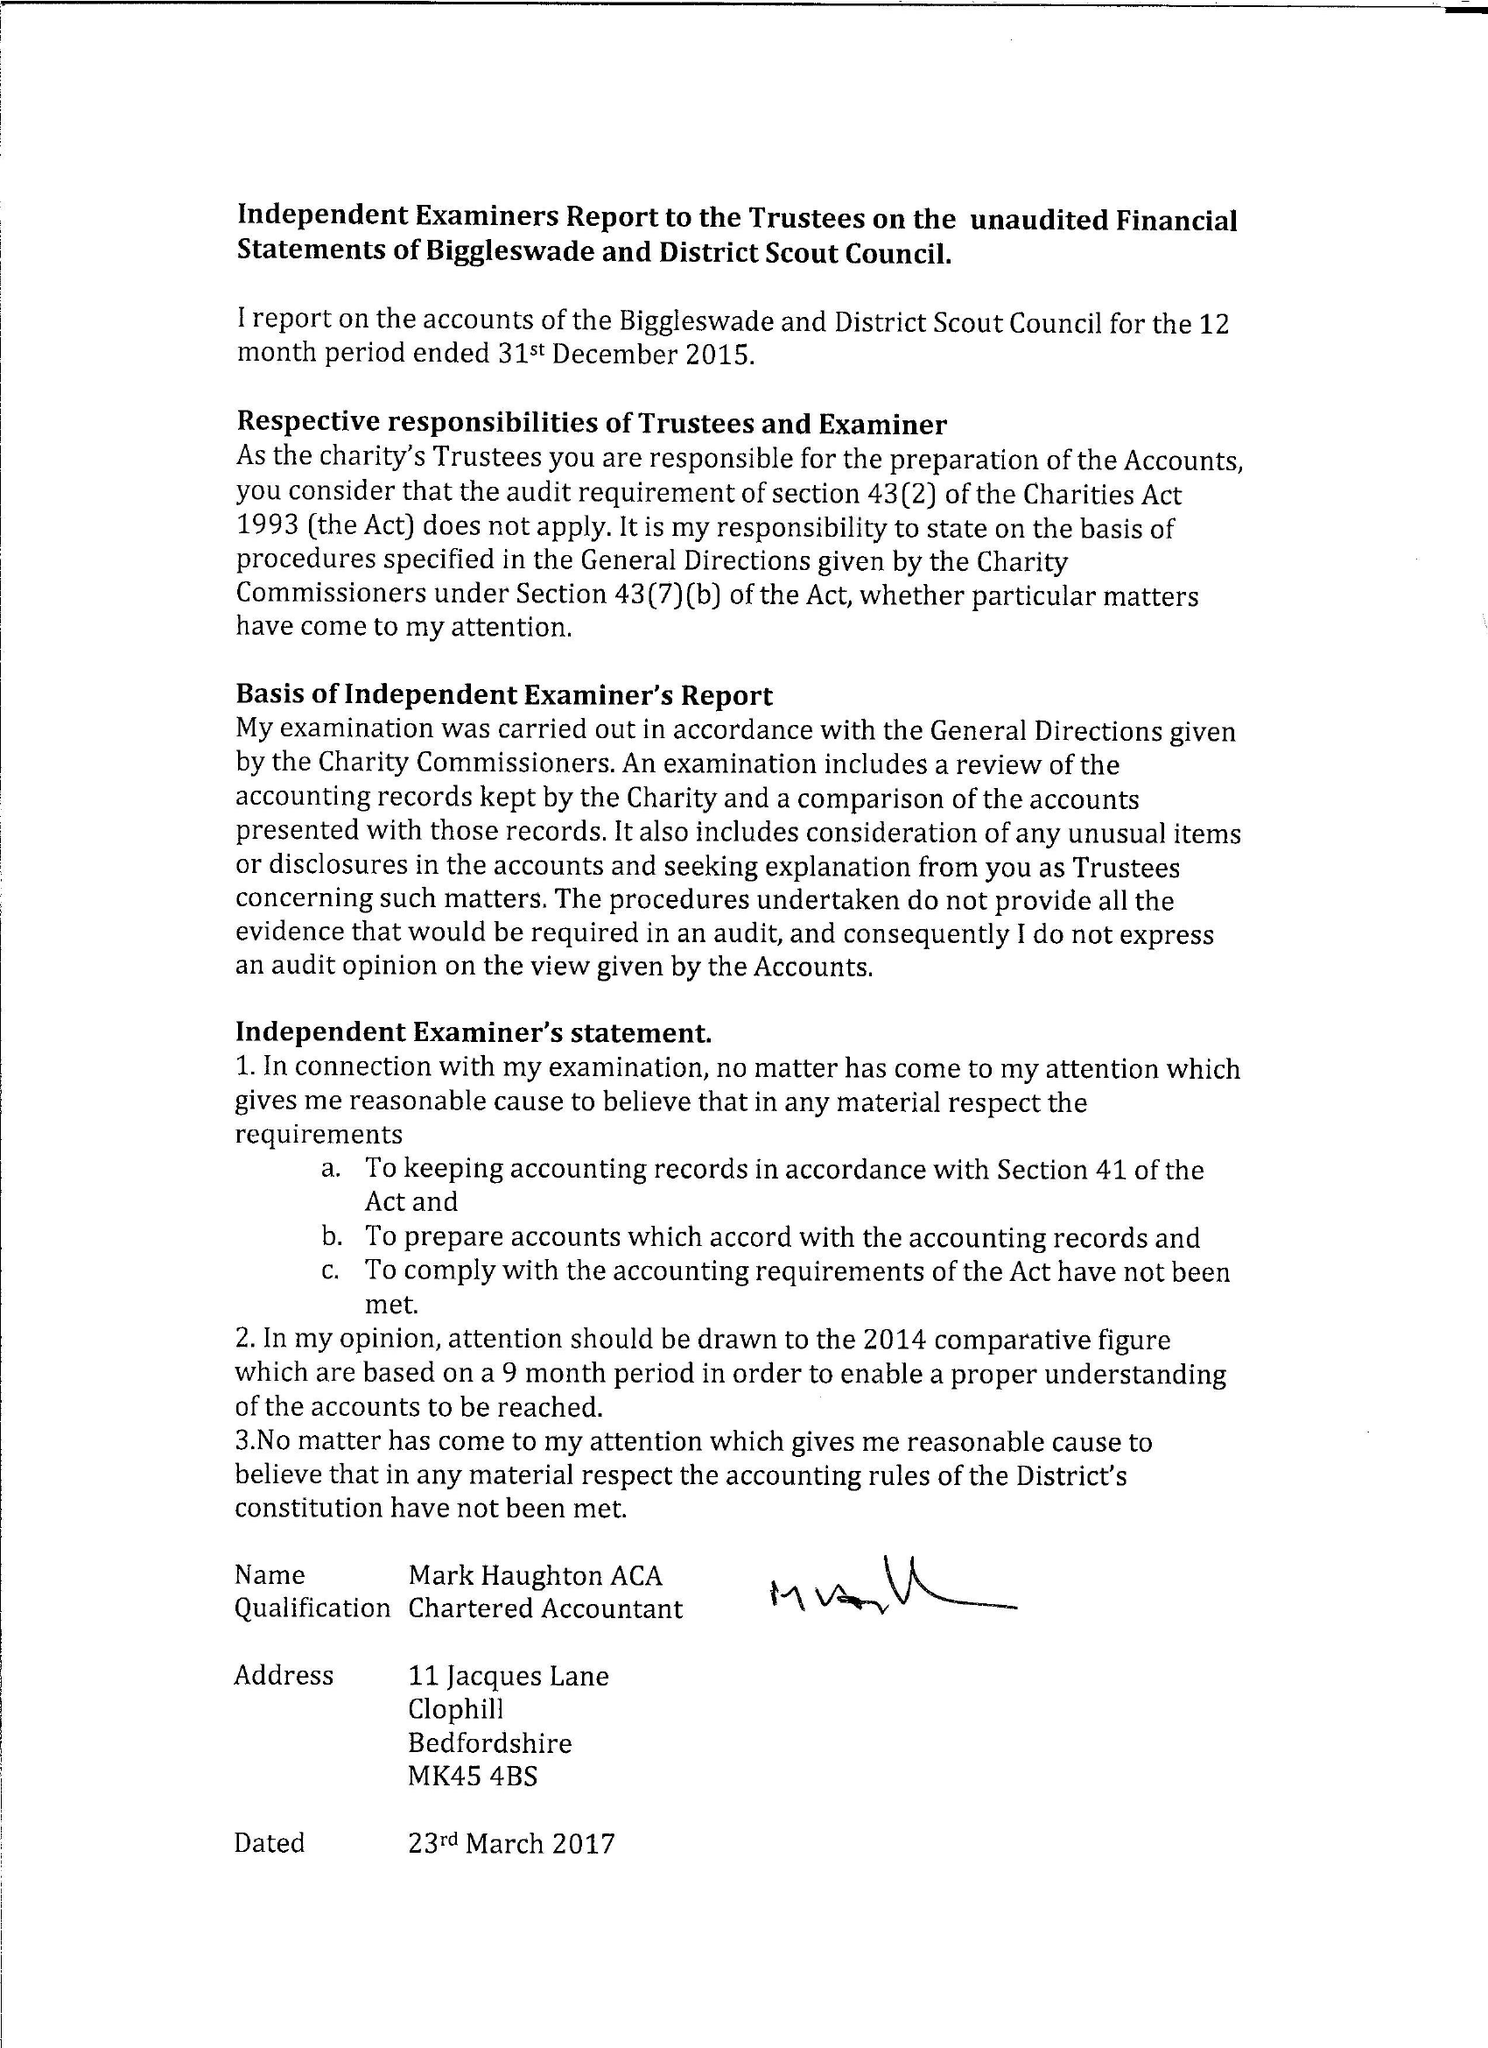What is the value for the report_date?
Answer the question using a single word or phrase. 2015-12-31 